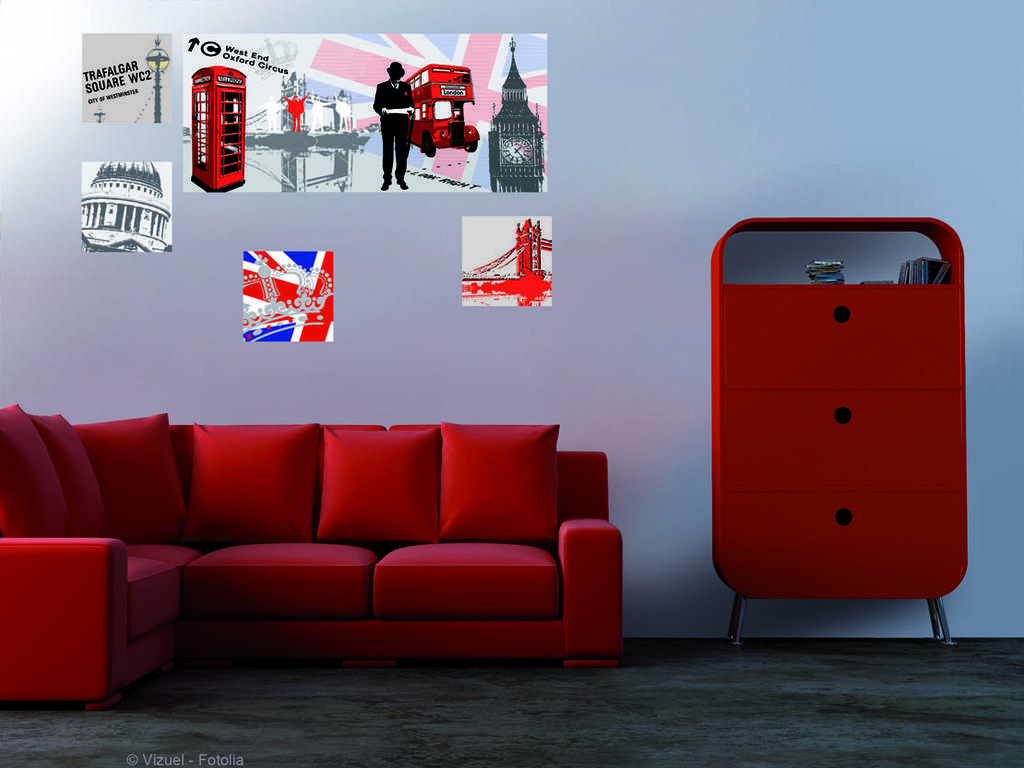Please provide a concise description of this image. There is a red color sofa and pillows are there on the sofa. Behind this there is a cup board and there are some items kept on the cupboard. In the wall there are some pictures. 